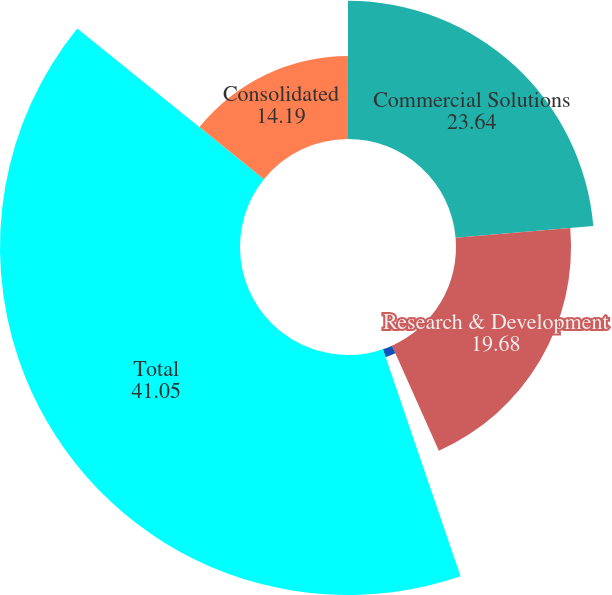<chart> <loc_0><loc_0><loc_500><loc_500><pie_chart><fcel>Commercial Solutions<fcel>Research & Development<fcel>Integrated Engagement Services<fcel>Total<fcel>Consolidated<nl><fcel>23.64%<fcel>19.68%<fcel>1.44%<fcel>41.05%<fcel>14.19%<nl></chart> 